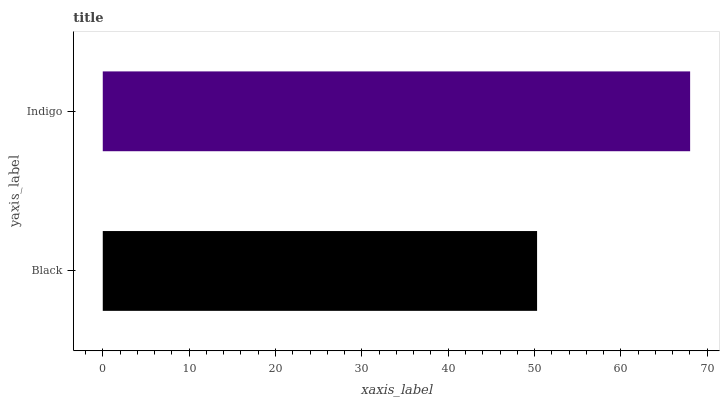Is Black the minimum?
Answer yes or no. Yes. Is Indigo the maximum?
Answer yes or no. Yes. Is Indigo the minimum?
Answer yes or no. No. Is Indigo greater than Black?
Answer yes or no. Yes. Is Black less than Indigo?
Answer yes or no. Yes. Is Black greater than Indigo?
Answer yes or no. No. Is Indigo less than Black?
Answer yes or no. No. Is Indigo the high median?
Answer yes or no. Yes. Is Black the low median?
Answer yes or no. Yes. Is Black the high median?
Answer yes or no. No. Is Indigo the low median?
Answer yes or no. No. 